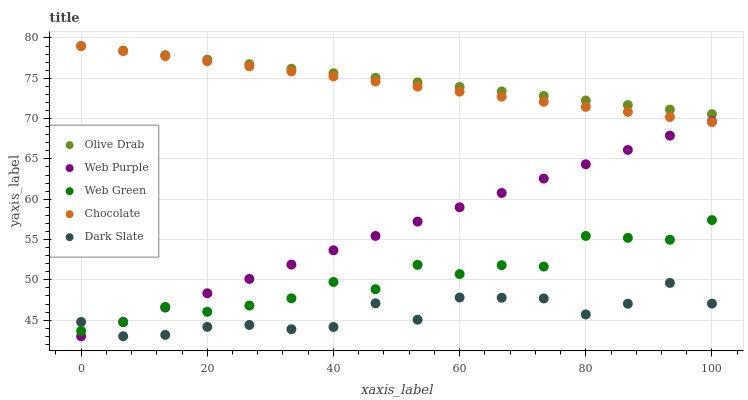Does Dark Slate have the minimum area under the curve?
Answer yes or no. Yes. Does Olive Drab have the maximum area under the curve?
Answer yes or no. Yes. Does Web Purple have the minimum area under the curve?
Answer yes or no. No. Does Web Purple have the maximum area under the curve?
Answer yes or no. No. Is Olive Drab the smoothest?
Answer yes or no. Yes. Is Dark Slate the roughest?
Answer yes or no. Yes. Is Web Purple the smoothest?
Answer yes or no. No. Is Web Purple the roughest?
Answer yes or no. No. Does Dark Slate have the lowest value?
Answer yes or no. Yes. Does Web Green have the lowest value?
Answer yes or no. No. Does Chocolate have the highest value?
Answer yes or no. Yes. Does Web Purple have the highest value?
Answer yes or no. No. Is Web Purple less than Olive Drab?
Answer yes or no. Yes. Is Chocolate greater than Dark Slate?
Answer yes or no. Yes. Does Web Purple intersect Web Green?
Answer yes or no. Yes. Is Web Purple less than Web Green?
Answer yes or no. No. Is Web Purple greater than Web Green?
Answer yes or no. No. Does Web Purple intersect Olive Drab?
Answer yes or no. No. 